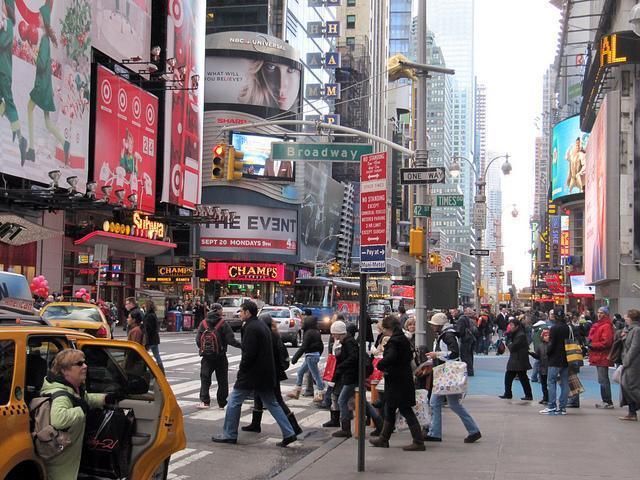How many people are in the picture?
Give a very brief answer. 5. How many tvs are there?
Give a very brief answer. 2. 